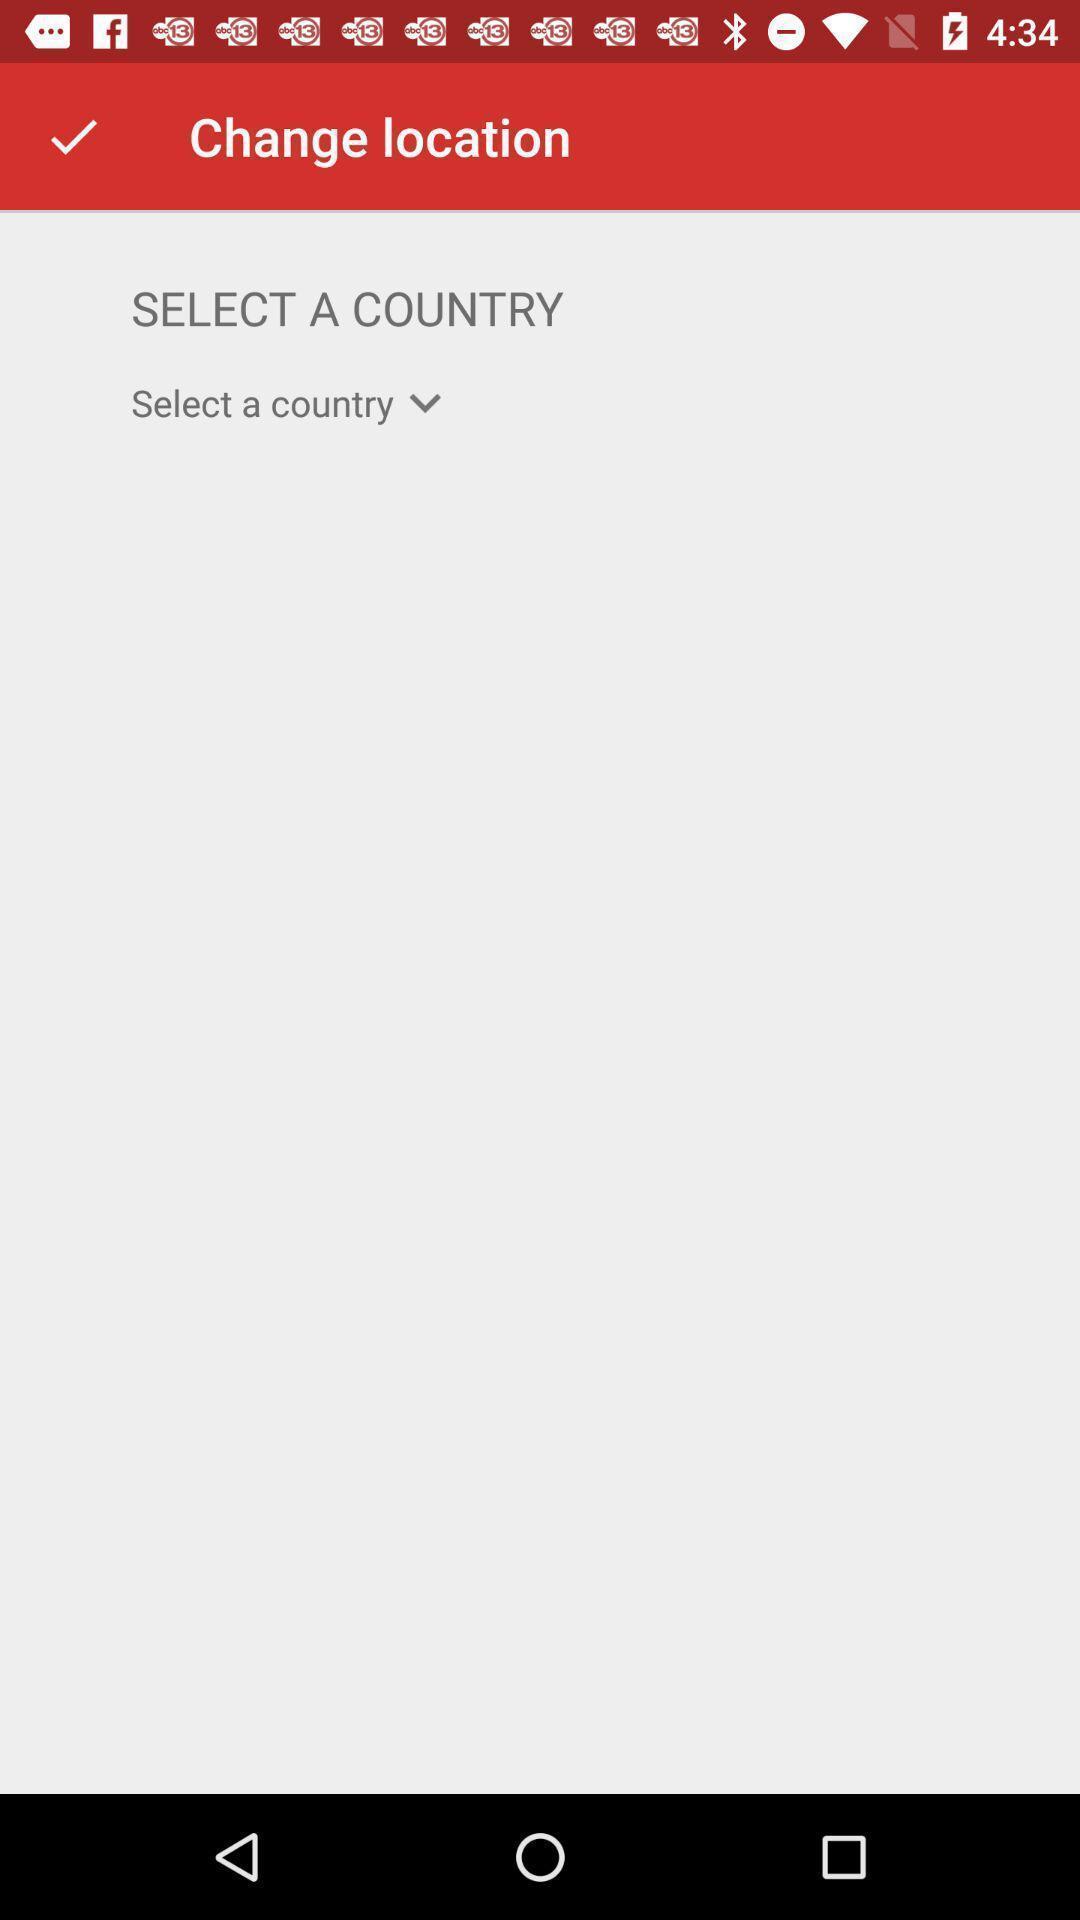Summarize the information in this screenshot. Page for selecting a country for location. 